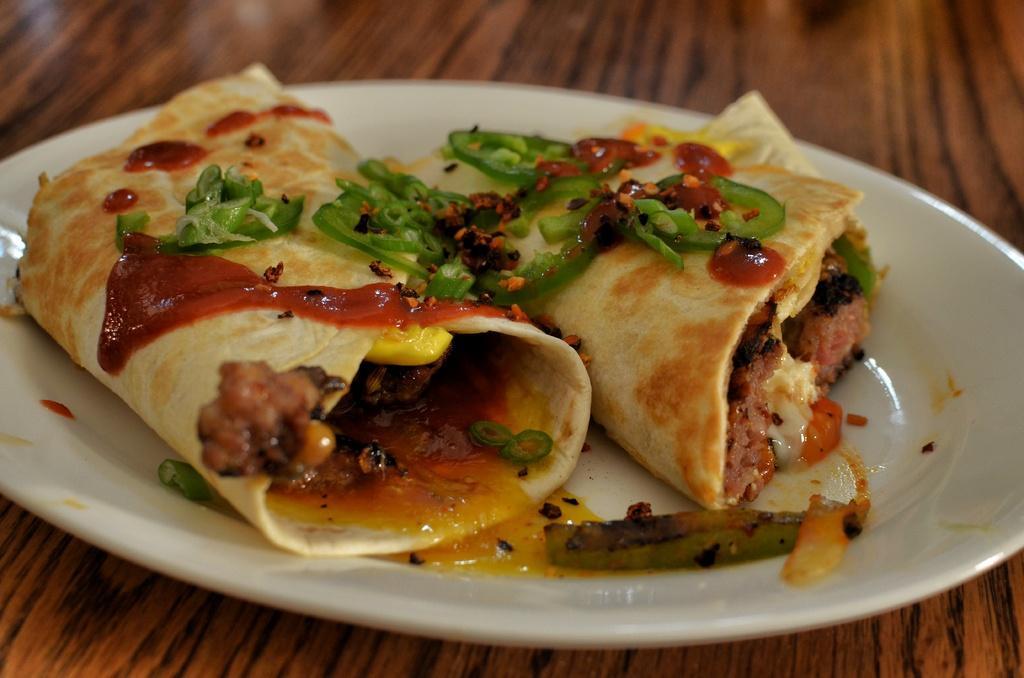Could you give a brief overview of what you see in this image? In this image there is a food item placed on a plate. 